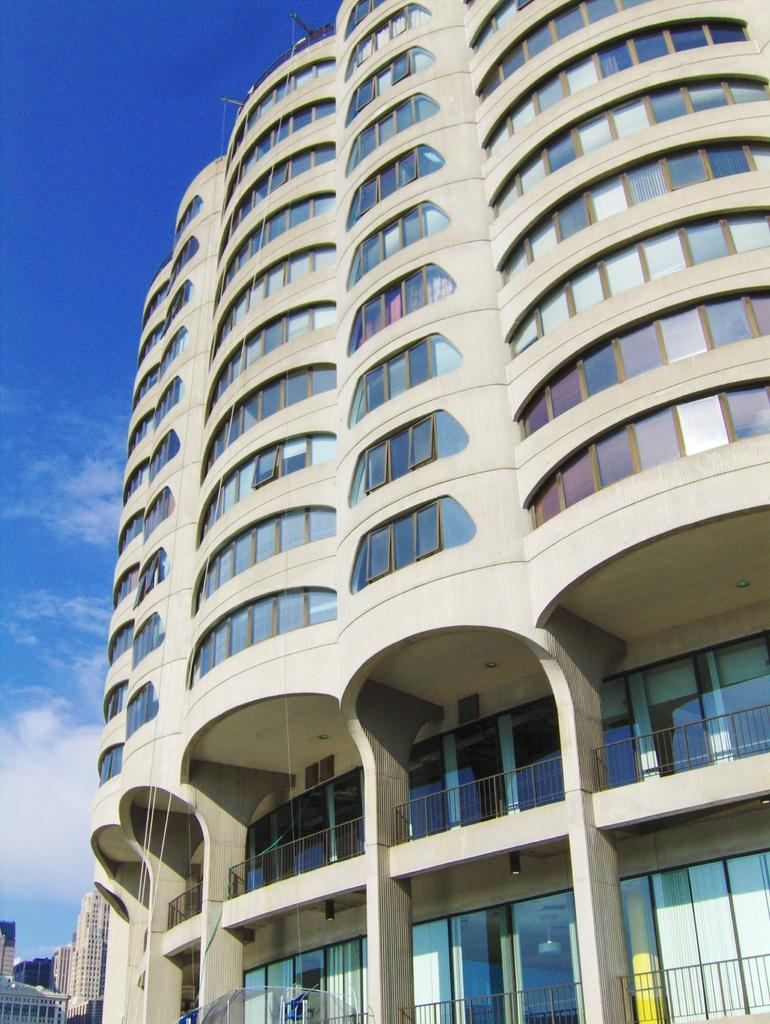What can be seen in the image? There are many buildings in the image. Can you describe the building on the right side of the image? The building on the right side of the image has glass windows and glass doors. What other features can be seen on the building? The building also has railings. What is visible at the top of the image? The sky is visible at the top of the image. Who is the friend arguing with at the table in the image? There is no friend or argument present in the image; it only features buildings and their features. 